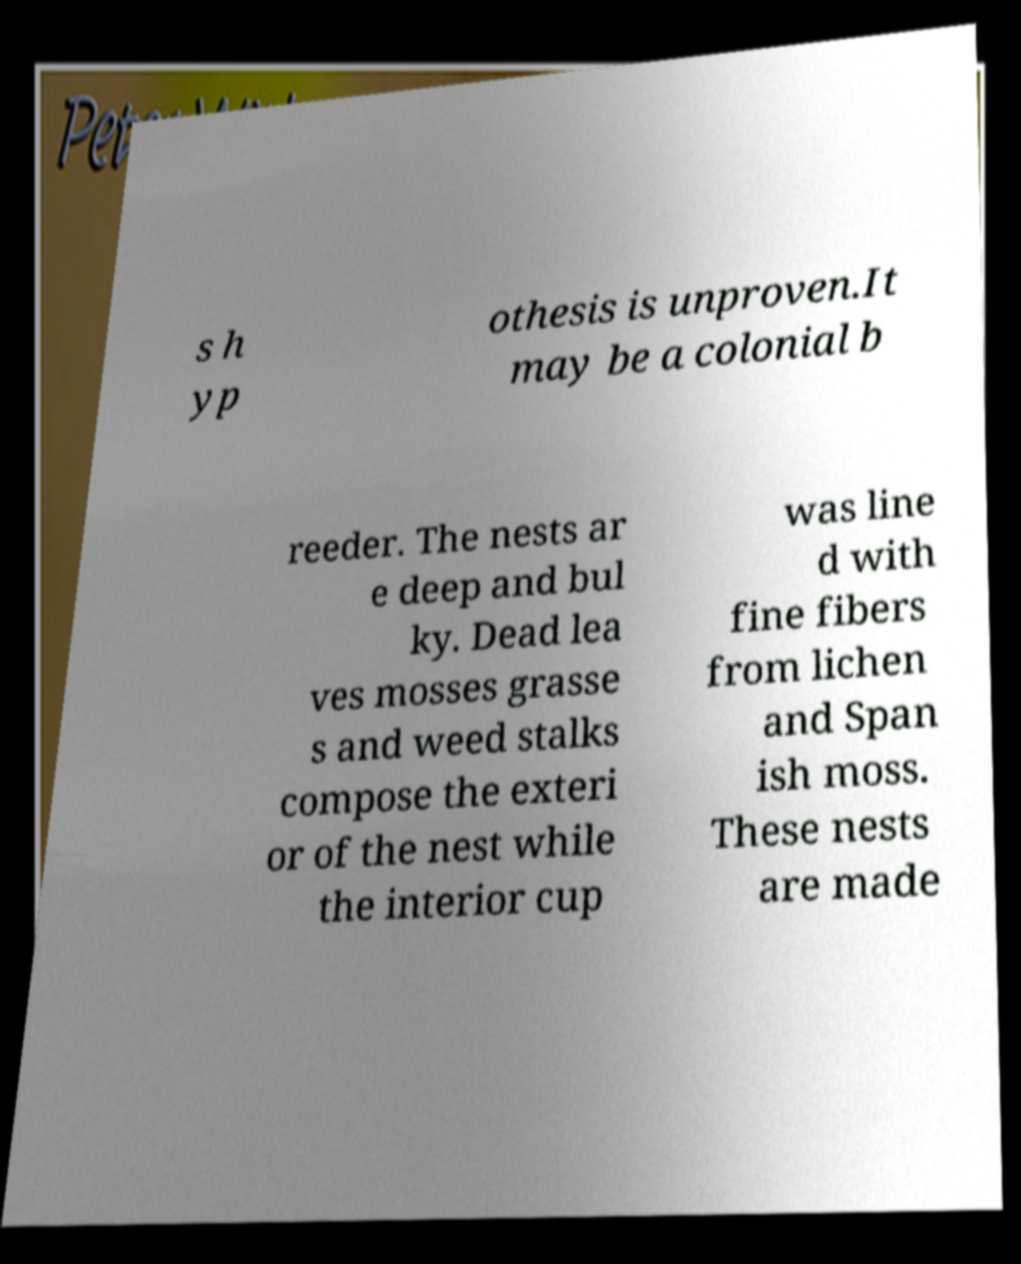I need the written content from this picture converted into text. Can you do that? s h yp othesis is unproven.It may be a colonial b reeder. The nests ar e deep and bul ky. Dead lea ves mosses grasse s and weed stalks compose the exteri or of the nest while the interior cup was line d with fine fibers from lichen and Span ish moss. These nests are made 